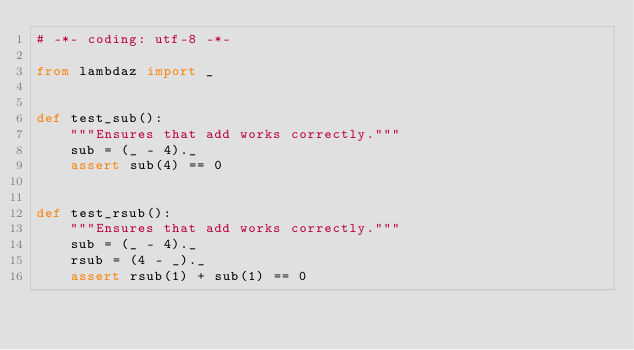<code> <loc_0><loc_0><loc_500><loc_500><_Python_># -*- coding: utf-8 -*-

from lambdaz import _


def test_sub():
    """Ensures that add works correctly."""
    sub = (_ - 4)._
    assert sub(4) == 0


def test_rsub():
    """Ensures that add works correctly."""
    sub = (_ - 4)._
    rsub = (4 - _)._
    assert rsub(1) + sub(1) == 0
</code> 